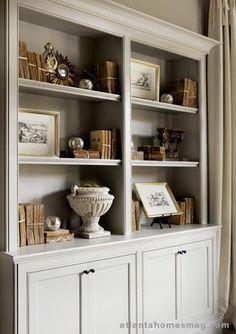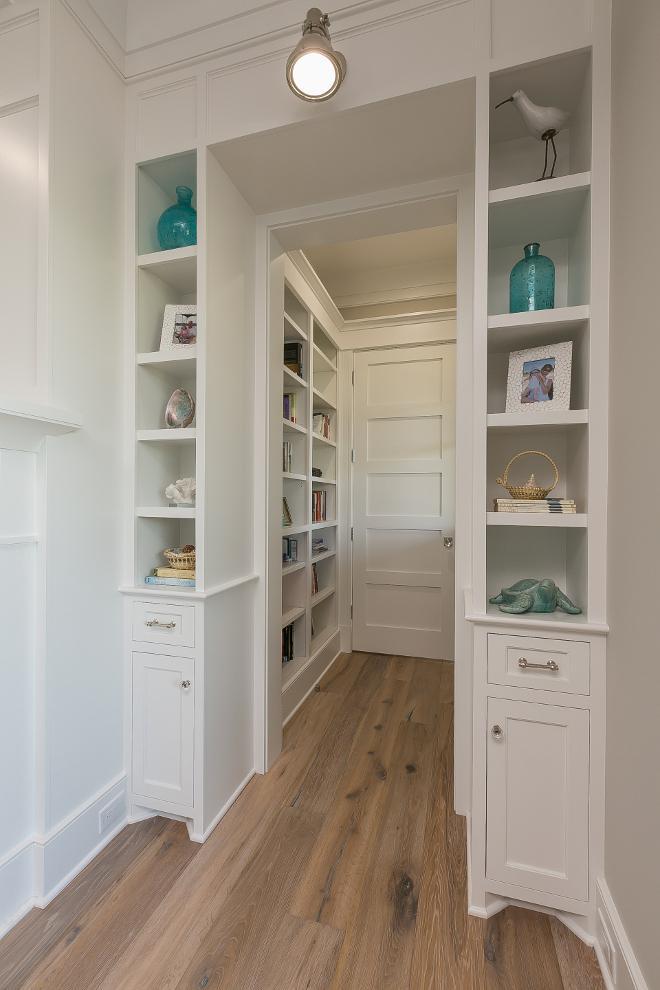The first image is the image on the left, the second image is the image on the right. Given the left and right images, does the statement "There is exactly one chair in the image on the left." hold true? Answer yes or no. No. 